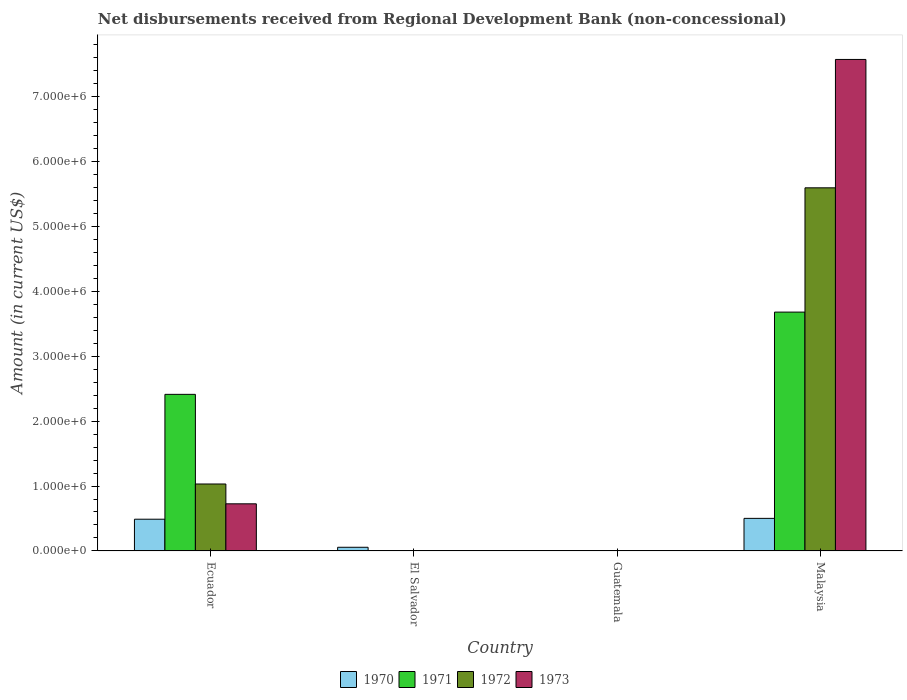How many different coloured bars are there?
Give a very brief answer. 4. Are the number of bars per tick equal to the number of legend labels?
Your response must be concise. No. How many bars are there on the 1st tick from the right?
Provide a short and direct response. 4. What is the label of the 3rd group of bars from the left?
Provide a short and direct response. Guatemala. What is the amount of disbursements received from Regional Development Bank in 1970 in El Salvador?
Your answer should be compact. 5.70e+04. Across all countries, what is the maximum amount of disbursements received from Regional Development Bank in 1971?
Keep it short and to the point. 3.68e+06. In which country was the amount of disbursements received from Regional Development Bank in 1970 maximum?
Provide a succinct answer. Malaysia. What is the total amount of disbursements received from Regional Development Bank in 1971 in the graph?
Provide a succinct answer. 6.09e+06. What is the difference between the amount of disbursements received from Regional Development Bank in 1970 in Ecuador and that in Malaysia?
Ensure brevity in your answer.  -1.30e+04. What is the difference between the amount of disbursements received from Regional Development Bank in 1970 in El Salvador and the amount of disbursements received from Regional Development Bank in 1973 in Ecuador?
Ensure brevity in your answer.  -6.69e+05. What is the average amount of disbursements received from Regional Development Bank in 1970 per country?
Your response must be concise. 2.62e+05. What is the difference between the amount of disbursements received from Regional Development Bank of/in 1973 and amount of disbursements received from Regional Development Bank of/in 1970 in Ecuador?
Offer a terse response. 2.37e+05. In how many countries, is the amount of disbursements received from Regional Development Bank in 1973 greater than 7600000 US$?
Keep it short and to the point. 0. What is the ratio of the amount of disbursements received from Regional Development Bank in 1970 in Ecuador to that in Malaysia?
Offer a very short reply. 0.97. Is the amount of disbursements received from Regional Development Bank in 1972 in Ecuador less than that in Malaysia?
Offer a terse response. Yes. What is the difference between the highest and the second highest amount of disbursements received from Regional Development Bank in 1970?
Your response must be concise. 1.30e+04. What is the difference between the highest and the lowest amount of disbursements received from Regional Development Bank in 1971?
Offer a terse response. 3.68e+06. Are all the bars in the graph horizontal?
Ensure brevity in your answer.  No. How many countries are there in the graph?
Provide a succinct answer. 4. Are the values on the major ticks of Y-axis written in scientific E-notation?
Provide a succinct answer. Yes. Does the graph contain any zero values?
Your answer should be very brief. Yes. Where does the legend appear in the graph?
Make the answer very short. Bottom center. What is the title of the graph?
Offer a terse response. Net disbursements received from Regional Development Bank (non-concessional). Does "1998" appear as one of the legend labels in the graph?
Offer a terse response. No. What is the Amount (in current US$) of 1970 in Ecuador?
Your response must be concise. 4.89e+05. What is the Amount (in current US$) in 1971 in Ecuador?
Make the answer very short. 2.41e+06. What is the Amount (in current US$) in 1972 in Ecuador?
Your answer should be very brief. 1.03e+06. What is the Amount (in current US$) in 1973 in Ecuador?
Your answer should be very brief. 7.26e+05. What is the Amount (in current US$) of 1970 in El Salvador?
Your answer should be compact. 5.70e+04. What is the Amount (in current US$) in 1972 in El Salvador?
Your answer should be very brief. 0. What is the Amount (in current US$) in 1973 in El Salvador?
Make the answer very short. 0. What is the Amount (in current US$) in 1971 in Guatemala?
Your answer should be compact. 0. What is the Amount (in current US$) in 1972 in Guatemala?
Give a very brief answer. 0. What is the Amount (in current US$) in 1973 in Guatemala?
Ensure brevity in your answer.  0. What is the Amount (in current US$) in 1970 in Malaysia?
Your response must be concise. 5.02e+05. What is the Amount (in current US$) of 1971 in Malaysia?
Make the answer very short. 3.68e+06. What is the Amount (in current US$) in 1972 in Malaysia?
Your answer should be compact. 5.59e+06. What is the Amount (in current US$) in 1973 in Malaysia?
Provide a short and direct response. 7.57e+06. Across all countries, what is the maximum Amount (in current US$) of 1970?
Offer a very short reply. 5.02e+05. Across all countries, what is the maximum Amount (in current US$) of 1971?
Offer a very short reply. 3.68e+06. Across all countries, what is the maximum Amount (in current US$) of 1972?
Your response must be concise. 5.59e+06. Across all countries, what is the maximum Amount (in current US$) in 1973?
Give a very brief answer. 7.57e+06. Across all countries, what is the minimum Amount (in current US$) in 1973?
Ensure brevity in your answer.  0. What is the total Amount (in current US$) in 1970 in the graph?
Offer a very short reply. 1.05e+06. What is the total Amount (in current US$) of 1971 in the graph?
Give a very brief answer. 6.09e+06. What is the total Amount (in current US$) of 1972 in the graph?
Provide a succinct answer. 6.62e+06. What is the total Amount (in current US$) in 1973 in the graph?
Provide a short and direct response. 8.29e+06. What is the difference between the Amount (in current US$) of 1970 in Ecuador and that in El Salvador?
Make the answer very short. 4.32e+05. What is the difference between the Amount (in current US$) of 1970 in Ecuador and that in Malaysia?
Offer a terse response. -1.30e+04. What is the difference between the Amount (in current US$) in 1971 in Ecuador and that in Malaysia?
Make the answer very short. -1.27e+06. What is the difference between the Amount (in current US$) of 1972 in Ecuador and that in Malaysia?
Ensure brevity in your answer.  -4.56e+06. What is the difference between the Amount (in current US$) of 1973 in Ecuador and that in Malaysia?
Make the answer very short. -6.84e+06. What is the difference between the Amount (in current US$) of 1970 in El Salvador and that in Malaysia?
Offer a terse response. -4.45e+05. What is the difference between the Amount (in current US$) in 1970 in Ecuador and the Amount (in current US$) in 1971 in Malaysia?
Your answer should be very brief. -3.19e+06. What is the difference between the Amount (in current US$) in 1970 in Ecuador and the Amount (in current US$) in 1972 in Malaysia?
Ensure brevity in your answer.  -5.10e+06. What is the difference between the Amount (in current US$) of 1970 in Ecuador and the Amount (in current US$) of 1973 in Malaysia?
Make the answer very short. -7.08e+06. What is the difference between the Amount (in current US$) of 1971 in Ecuador and the Amount (in current US$) of 1972 in Malaysia?
Offer a terse response. -3.18e+06. What is the difference between the Amount (in current US$) in 1971 in Ecuador and the Amount (in current US$) in 1973 in Malaysia?
Give a very brief answer. -5.16e+06. What is the difference between the Amount (in current US$) of 1972 in Ecuador and the Amount (in current US$) of 1973 in Malaysia?
Offer a very short reply. -6.54e+06. What is the difference between the Amount (in current US$) in 1970 in El Salvador and the Amount (in current US$) in 1971 in Malaysia?
Provide a short and direct response. -3.62e+06. What is the difference between the Amount (in current US$) in 1970 in El Salvador and the Amount (in current US$) in 1972 in Malaysia?
Provide a succinct answer. -5.53e+06. What is the difference between the Amount (in current US$) of 1970 in El Salvador and the Amount (in current US$) of 1973 in Malaysia?
Offer a terse response. -7.51e+06. What is the average Amount (in current US$) in 1970 per country?
Provide a short and direct response. 2.62e+05. What is the average Amount (in current US$) of 1971 per country?
Make the answer very short. 1.52e+06. What is the average Amount (in current US$) of 1972 per country?
Offer a terse response. 1.66e+06. What is the average Amount (in current US$) of 1973 per country?
Offer a terse response. 2.07e+06. What is the difference between the Amount (in current US$) of 1970 and Amount (in current US$) of 1971 in Ecuador?
Keep it short and to the point. -1.92e+06. What is the difference between the Amount (in current US$) of 1970 and Amount (in current US$) of 1972 in Ecuador?
Offer a terse response. -5.42e+05. What is the difference between the Amount (in current US$) in 1970 and Amount (in current US$) in 1973 in Ecuador?
Ensure brevity in your answer.  -2.37e+05. What is the difference between the Amount (in current US$) of 1971 and Amount (in current US$) of 1972 in Ecuador?
Ensure brevity in your answer.  1.38e+06. What is the difference between the Amount (in current US$) of 1971 and Amount (in current US$) of 1973 in Ecuador?
Make the answer very short. 1.68e+06. What is the difference between the Amount (in current US$) in 1972 and Amount (in current US$) in 1973 in Ecuador?
Your answer should be compact. 3.05e+05. What is the difference between the Amount (in current US$) of 1970 and Amount (in current US$) of 1971 in Malaysia?
Offer a terse response. -3.18e+06. What is the difference between the Amount (in current US$) in 1970 and Amount (in current US$) in 1972 in Malaysia?
Provide a short and direct response. -5.09e+06. What is the difference between the Amount (in current US$) of 1970 and Amount (in current US$) of 1973 in Malaysia?
Make the answer very short. -7.06e+06. What is the difference between the Amount (in current US$) in 1971 and Amount (in current US$) in 1972 in Malaysia?
Provide a succinct answer. -1.91e+06. What is the difference between the Amount (in current US$) in 1971 and Amount (in current US$) in 1973 in Malaysia?
Your response must be concise. -3.89e+06. What is the difference between the Amount (in current US$) in 1972 and Amount (in current US$) in 1973 in Malaysia?
Give a very brief answer. -1.98e+06. What is the ratio of the Amount (in current US$) in 1970 in Ecuador to that in El Salvador?
Offer a terse response. 8.58. What is the ratio of the Amount (in current US$) of 1970 in Ecuador to that in Malaysia?
Your answer should be compact. 0.97. What is the ratio of the Amount (in current US$) in 1971 in Ecuador to that in Malaysia?
Offer a very short reply. 0.66. What is the ratio of the Amount (in current US$) in 1972 in Ecuador to that in Malaysia?
Keep it short and to the point. 0.18. What is the ratio of the Amount (in current US$) of 1973 in Ecuador to that in Malaysia?
Keep it short and to the point. 0.1. What is the ratio of the Amount (in current US$) of 1970 in El Salvador to that in Malaysia?
Offer a very short reply. 0.11. What is the difference between the highest and the second highest Amount (in current US$) of 1970?
Make the answer very short. 1.30e+04. What is the difference between the highest and the lowest Amount (in current US$) in 1970?
Provide a succinct answer. 5.02e+05. What is the difference between the highest and the lowest Amount (in current US$) in 1971?
Make the answer very short. 3.68e+06. What is the difference between the highest and the lowest Amount (in current US$) in 1972?
Offer a very short reply. 5.59e+06. What is the difference between the highest and the lowest Amount (in current US$) in 1973?
Give a very brief answer. 7.57e+06. 